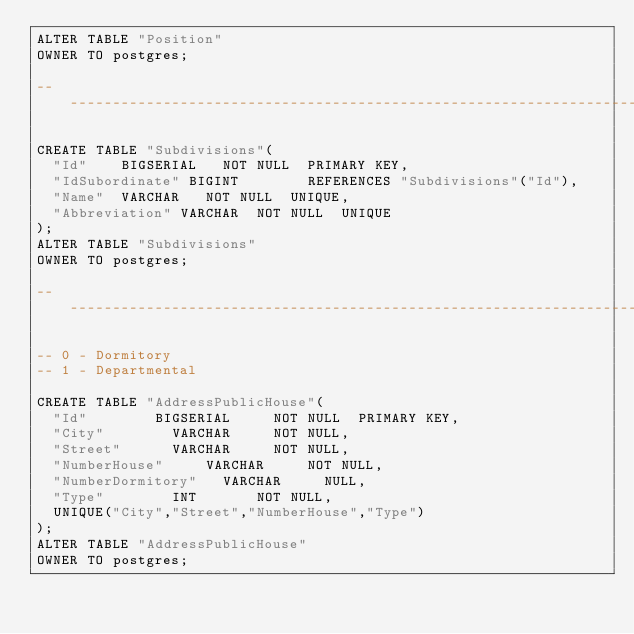<code> <loc_0><loc_0><loc_500><loc_500><_SQL_>ALTER TABLE "Position"
OWNER TO postgres;

-----------------------------------------------------------------------------------------------------------------------------------------------

CREATE TABLE "Subdivisions"(
	"Id" 		BIGSERIAL 	NOT NULL 	PRIMARY KEY,
	"IdSubordinate" BIGINT 				REFERENCES "Subdivisions"("Id"),
	"Name" 	VARCHAR 	NOT NULL 	UNIQUE,
	"Abbreviation" VARCHAR  NOT NULL 	UNIQUE
);
ALTER TABLE "Subdivisions"
OWNER TO postgres;

-----------------------------------------------------------------------------------------------------------------------------------------------

-- 0 - Dormitory
-- 1 - Departmental

CREATE TABLE "AddressPublicHouse"(
	"Id" 				BIGSERIAL 		NOT NULL 	PRIMARY KEY,
	"City" 				VARCHAR 		NOT NULL,
	"Street" 			VARCHAR 		NOT NULL,
	"NumberHouse" 		VARCHAR 		NOT NULL,
	"NumberDormitory" 	VARCHAR 		NULL,
	"Type" 				INT 			NOT NULL,
	UNIQUE("City","Street","NumberHouse","Type")
);
ALTER TABLE "AddressPublicHouse"
OWNER TO postgres;</code> 